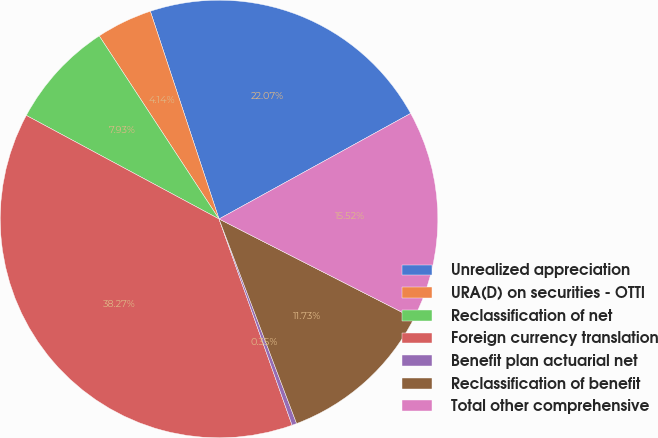Convert chart. <chart><loc_0><loc_0><loc_500><loc_500><pie_chart><fcel>Unrealized appreciation<fcel>URA(D) on securities - OTTI<fcel>Reclassification of net<fcel>Foreign currency translation<fcel>Benefit plan actuarial net<fcel>Reclassification of benefit<fcel>Total other comprehensive<nl><fcel>22.07%<fcel>4.14%<fcel>7.93%<fcel>38.27%<fcel>0.35%<fcel>11.73%<fcel>15.52%<nl></chart> 